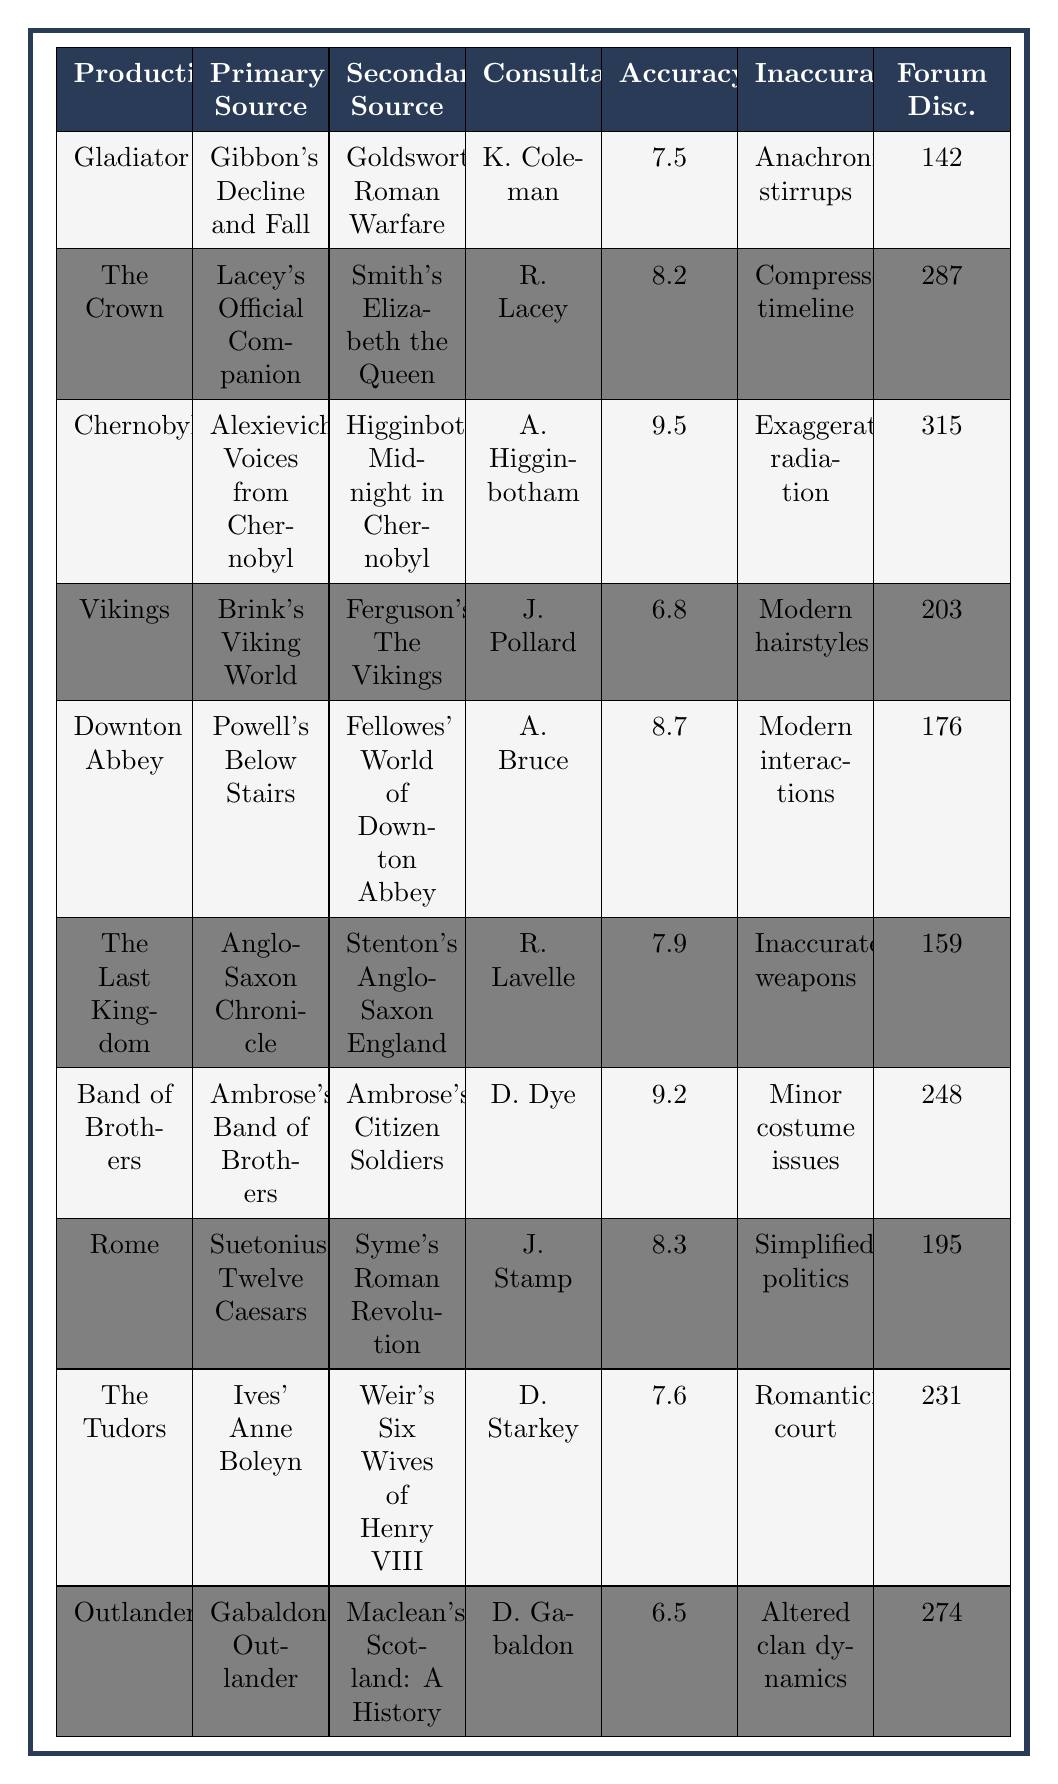What is the accuracy rating of "Chernobyl"? The table lists the accuracy rating for "Chernobyl" as 9.5 in the Accuracy Rating column.
Answer: 9.5 Who was the historical consultant for "The Tudors"? The table shows that David Starkey was the historical consultant listed for "The Tudors" in the Historical Consultant column.
Answer: David Starkey Which production has the highest accuracy rating? Comparing all accuracy ratings in the table, "Chernobyl" has the highest rating of 9.5, higher than any other.
Answer: Chernobyl How many forum discussions are there for "Downton Abbey"? The table indicates that there are 176 forum discussions related to "Downton Abbey" as listed in the Forum Discussions column.
Answer: 176 What is the average accuracy rating of the listed productions? Adding all the accuracy ratings: 7.5 + 8.2 + 9.5 + 6.8 + 8.7 + 7.9 + 9.2 + 8.3 + 7.6 + 6.5 = 78.2; dividing by the total count (10), so the average is 78.2/10 = 7.82.
Answer: 7.82 Is "Gladiator" associated with any notable inaccuracies regarding weapon designs? The table lists "Inaccurate weapon designs" as a notable inaccuracy for "Gladiator". Thus, it is true.
Answer: Yes What is the notable inaccuracy associated with "Vikings"? The table highlights "Modern hairstyles and makeup" as the notable inaccuracy linked to "Vikings" in the Notable Inaccuracies column.
Answer: Modern hairstyles and makeup Which production cited “Voices from Chernobyl” as its primary historical source? "Chernobyl" is the production that cites “Voices from Chernobyl” as per the Primary Historical Source column.
Answer: Chernobyl How many productions have an accuracy rating higher than 8.0? Checking the accuracy ratings: "The Crown" (8.2), "Chernobyl" (9.5), "Downton Abbey" (8.7), "Band of Brothers" (9.2), "Rome" (8.3), totals to 5 productions with a rating higher than 8.0.
Answer: 5 What is one notable inaccuracy for "Outlander"? According to the table, "Altered clan dynamics" is indicated as a notable inaccuracy for "Outlander".
Answer: Altered clan dynamics Which secondary source is cited by "The Last Kingdom"? The secondary source cited for "The Last Kingdom" is "Anglo-Saxon England" by Frank Stenton, as shown in the Secondary Source column.
Answer: Anglo-Saxon England by Frank Stenton 